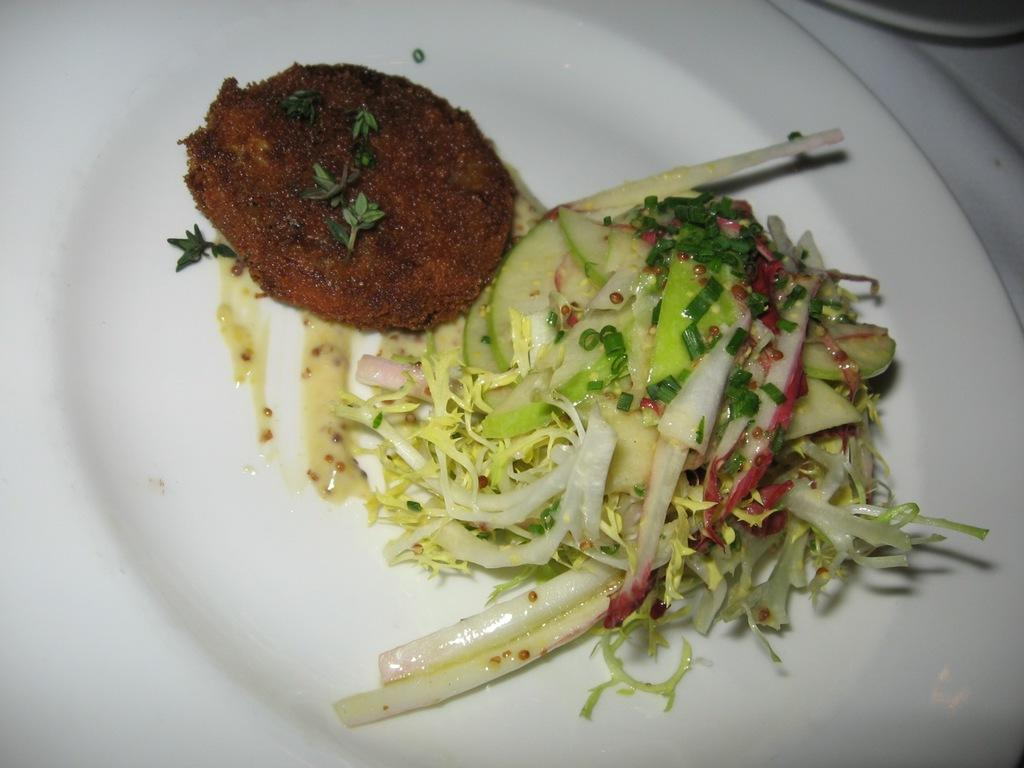What type of places are visible in the image? There are food places in the image. What is the color of the plate on which the food places are located? The food places are on a white color plate. What colors can be seen in the food? The food has green and brown colors. What type of haircut is being offered at the food places in the image? There is no indication of haircuts being offered at the food places in the image. 